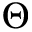Convert formula to latex. <formula><loc_0><loc_0><loc_500><loc_500>\Theta</formula> 